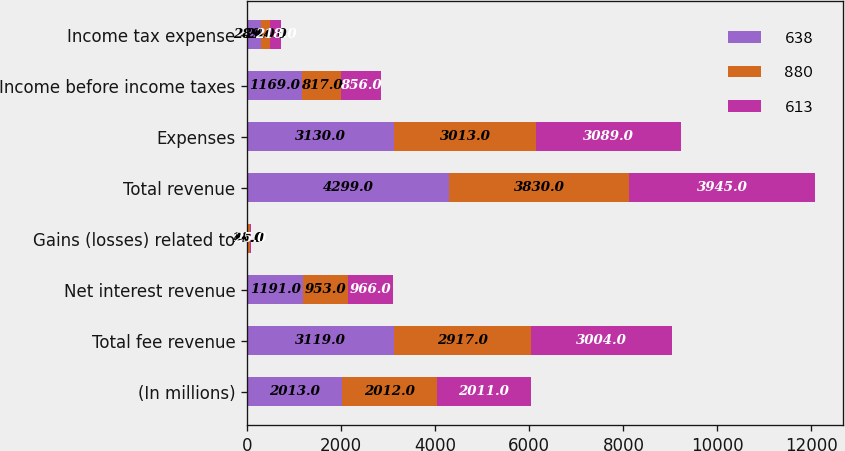Convert chart to OTSL. <chart><loc_0><loc_0><loc_500><loc_500><stacked_bar_chart><ecel><fcel>(In millions)<fcel>Total fee revenue<fcel>Net interest revenue<fcel>Gains (losses) related to<fcel>Total revenue<fcel>Expenses<fcel>Income before income taxes<fcel>Income tax expense<nl><fcel>638<fcel>2013<fcel>3119<fcel>1191<fcel>11<fcel>4299<fcel>3130<fcel>1169<fcel>289<nl><fcel>880<fcel>2012<fcel>2917<fcel>953<fcel>40<fcel>3830<fcel>3013<fcel>817<fcel>204<nl><fcel>613<fcel>2011<fcel>3004<fcel>966<fcel>25<fcel>3945<fcel>3089<fcel>856<fcel>218<nl></chart> 